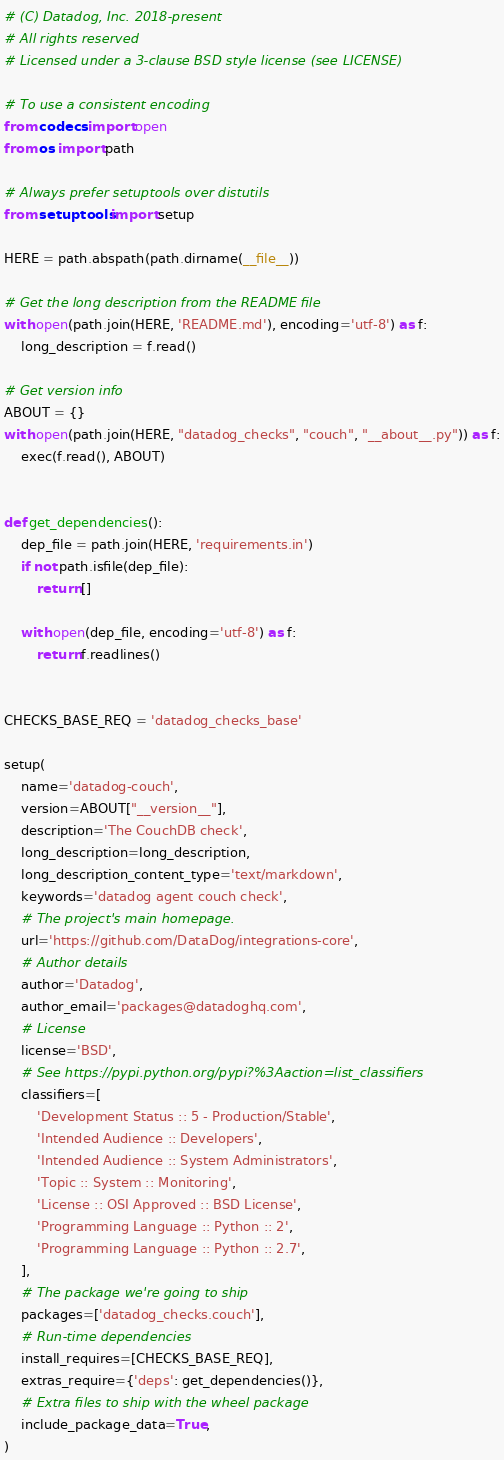<code> <loc_0><loc_0><loc_500><loc_500><_Python_># (C) Datadog, Inc. 2018-present
# All rights reserved
# Licensed under a 3-clause BSD style license (see LICENSE)

# To use a consistent encoding
from codecs import open
from os import path

# Always prefer setuptools over distutils
from setuptools import setup

HERE = path.abspath(path.dirname(__file__))

# Get the long description from the README file
with open(path.join(HERE, 'README.md'), encoding='utf-8') as f:
    long_description = f.read()

# Get version info
ABOUT = {}
with open(path.join(HERE, "datadog_checks", "couch", "__about__.py")) as f:
    exec(f.read(), ABOUT)


def get_dependencies():
    dep_file = path.join(HERE, 'requirements.in')
    if not path.isfile(dep_file):
        return []

    with open(dep_file, encoding='utf-8') as f:
        return f.readlines()


CHECKS_BASE_REQ = 'datadog_checks_base'

setup(
    name='datadog-couch',
    version=ABOUT["__version__"],
    description='The CouchDB check',
    long_description=long_description,
    long_description_content_type='text/markdown',
    keywords='datadog agent couch check',
    # The project's main homepage.
    url='https://github.com/DataDog/integrations-core',
    # Author details
    author='Datadog',
    author_email='packages@datadoghq.com',
    # License
    license='BSD',
    # See https://pypi.python.org/pypi?%3Aaction=list_classifiers
    classifiers=[
        'Development Status :: 5 - Production/Stable',
        'Intended Audience :: Developers',
        'Intended Audience :: System Administrators',
        'Topic :: System :: Monitoring',
        'License :: OSI Approved :: BSD License',
        'Programming Language :: Python :: 2',
        'Programming Language :: Python :: 2.7',
    ],
    # The package we're going to ship
    packages=['datadog_checks.couch'],
    # Run-time dependencies
    install_requires=[CHECKS_BASE_REQ],
    extras_require={'deps': get_dependencies()},
    # Extra files to ship with the wheel package
    include_package_data=True,
)
</code> 